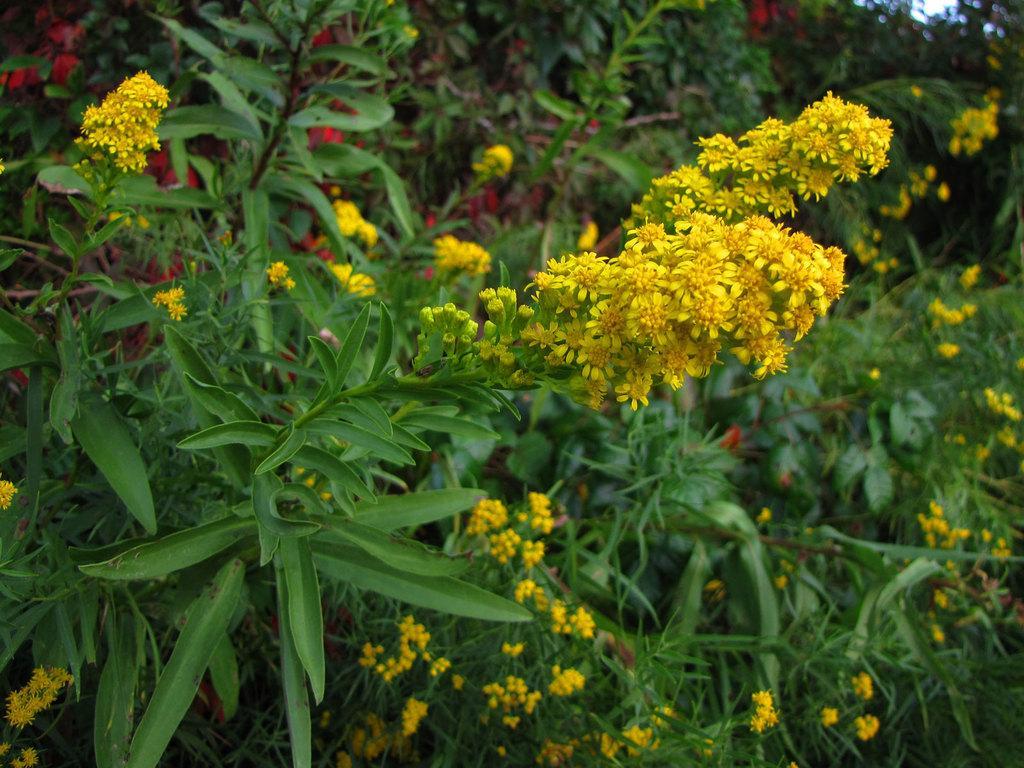In one or two sentences, can you explain what this image depicts? In this image there are some plants, flowers and grass. 